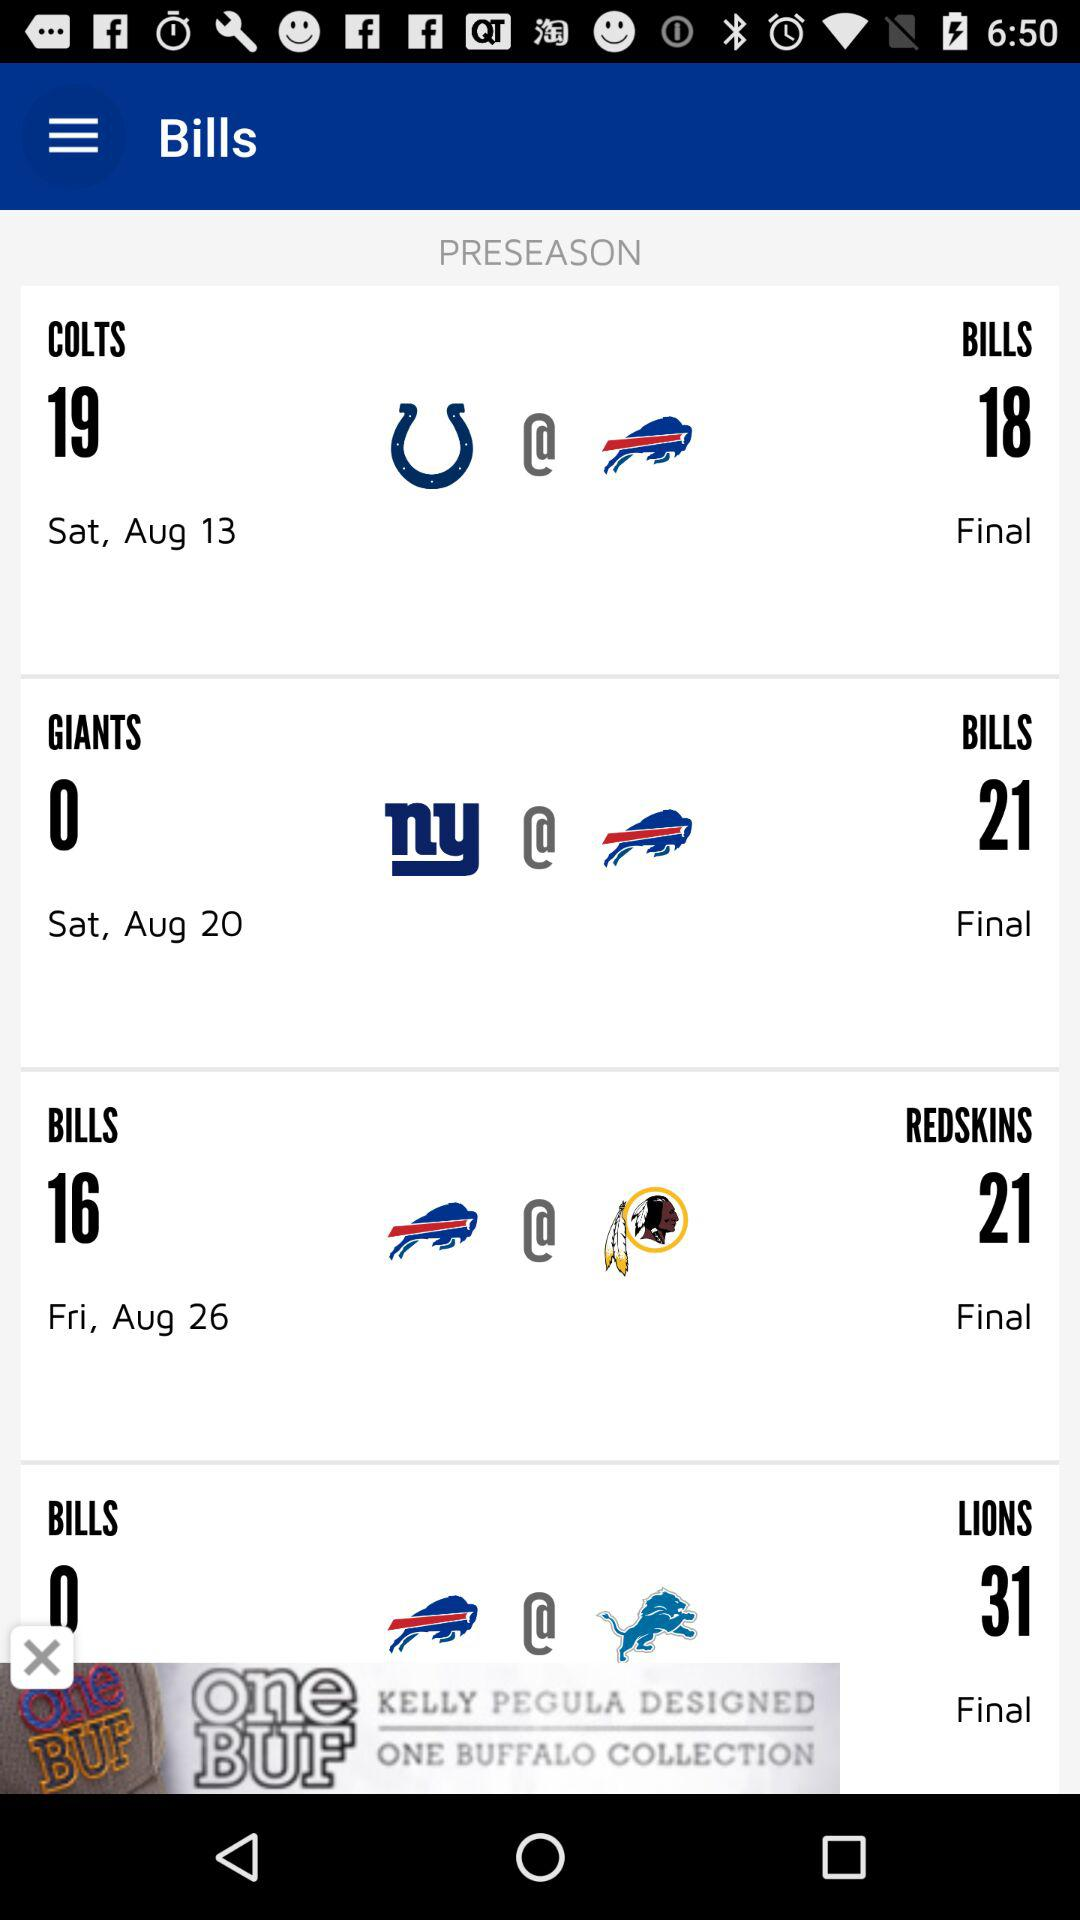What is the score of "COLTS" on Saturday, August 13? The score of "COLTS" is 19. 